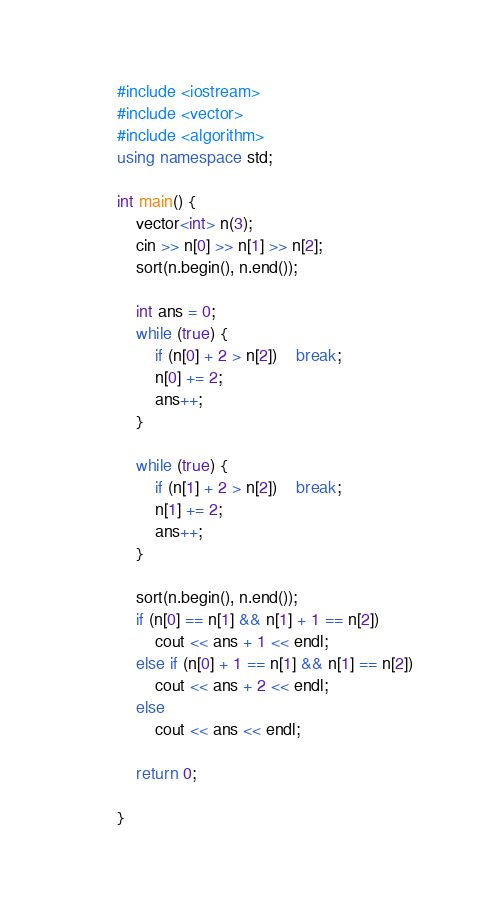Convert code to text. <code><loc_0><loc_0><loc_500><loc_500><_C++_>#include <iostream>
#include <vector>
#include <algorithm>
using namespace std;

int main() {
	vector<int> n(3);
	cin >> n[0] >> n[1] >> n[2];
	sort(n.begin(), n.end());

	int ans = 0;
	while (true) {
		if (n[0] + 2 > n[2])	break;
		n[0] += 2;
		ans++;
	}
	
	while (true) {
		if (n[1] + 2 > n[2])	break;
		n[1] += 2;
		ans++;
	}
	
	sort(n.begin(), n.end());
	if (n[0] == n[1] && n[1] + 1 == n[2])
		cout << ans + 1 << endl;
	else if (n[0] + 1 == n[1] && n[1] == n[2])
		cout << ans + 2 << endl;
	else
		cout << ans << endl;
	
	return 0;

}</code> 